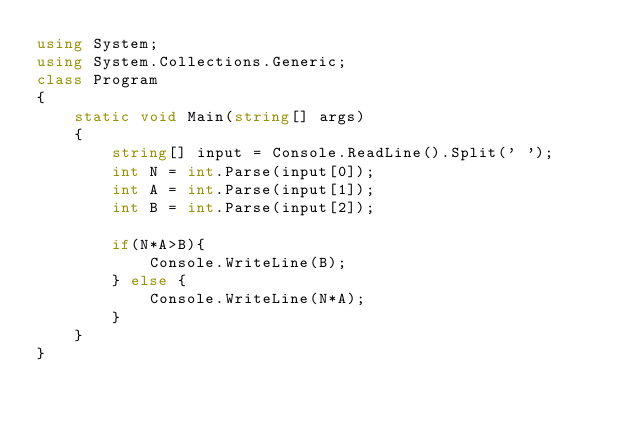Convert code to text. <code><loc_0><loc_0><loc_500><loc_500><_C#_>using System;
using System.Collections.Generic;
class Program
{
    static void Main(string[] args)
    {
        string[] input = Console.ReadLine().Split(' ');
        int N = int.Parse(input[0]);
        int A = int.Parse(input[1]);
        int B = int.Parse(input[2]);

        if(N*A>B){
            Console.WriteLine(B);
        } else {
            Console.WriteLine(N*A);
        }
    }
}</code> 